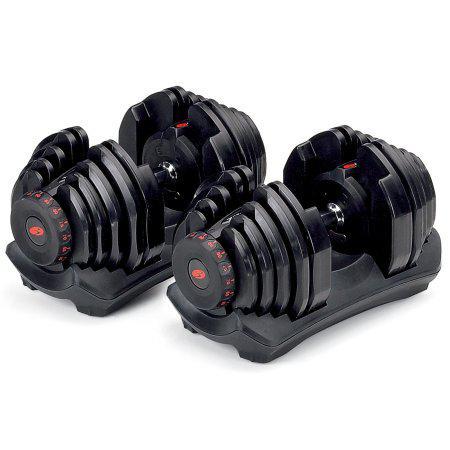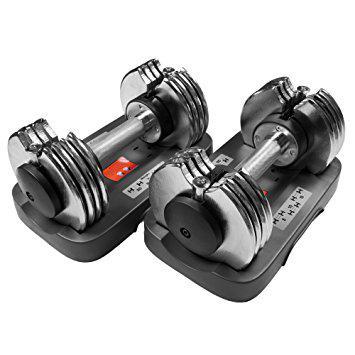The first image is the image on the left, the second image is the image on the right. Given the left and right images, does the statement "The combined images include three dumbbell bars with weights on each end." hold true? Answer yes or no. No. The first image is the image on the left, the second image is the image on the right. For the images shown, is this caption "The left and right image contains a total of three dumbbells." true? Answer yes or no. No. 